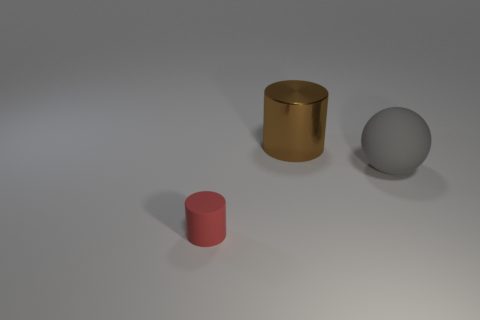Add 2 large brown cylinders. How many objects exist? 5 Subtract all spheres. How many objects are left? 2 Subtract all big metal cylinders. Subtract all big metallic things. How many objects are left? 1 Add 3 tiny rubber cylinders. How many tiny rubber cylinders are left? 4 Add 2 big gray things. How many big gray things exist? 3 Subtract 0 gray cylinders. How many objects are left? 3 